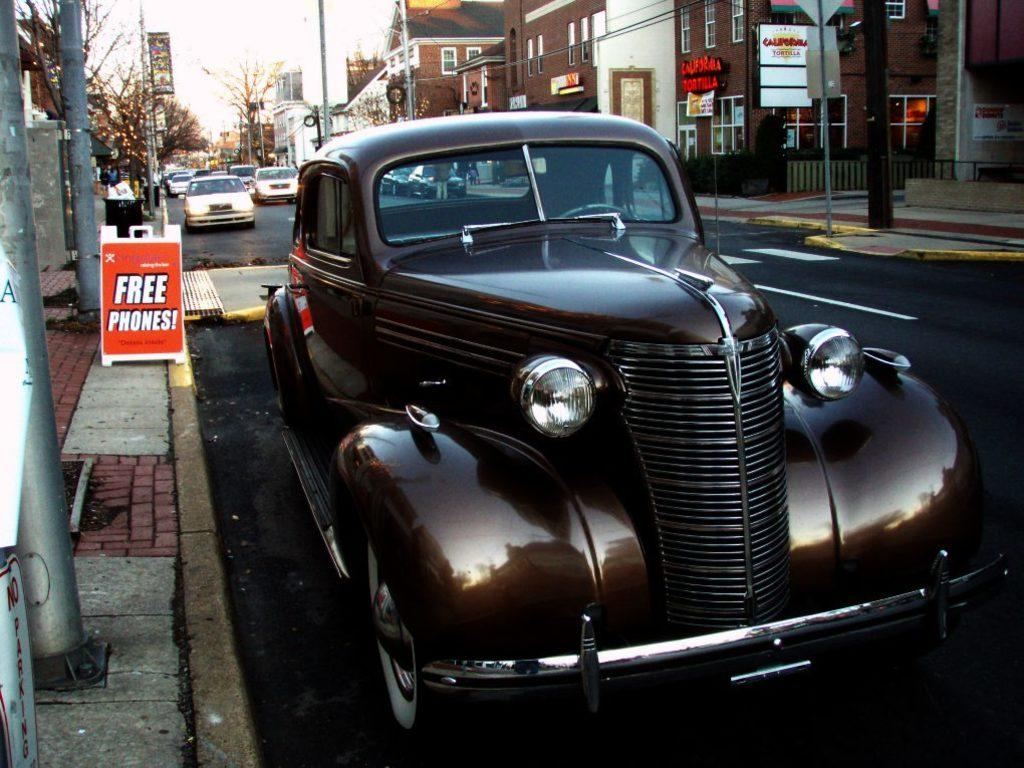<image>
Give a short and clear explanation of the subsequent image. Free Phones sign that is on the side of a road with an old car parked. 